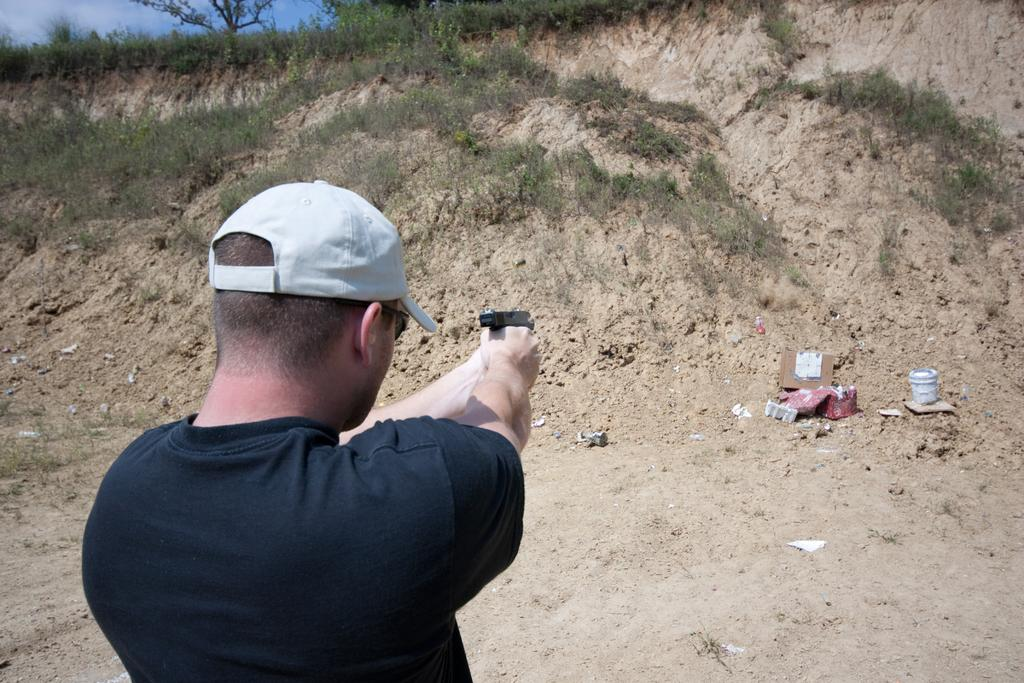Who is present in the image? There is a man in the image. What is the man wearing on his head? The man is wearing a cap. What is the man holding in his hand? The man is holding a gun. What objects are in front of the man? There are boxes and plants in front of the man. What type of vegetation is visible in front of the man? There are trees in front of the man. What type of doll is sitting on the cloth in the image? There is no doll or cloth present in the image. 